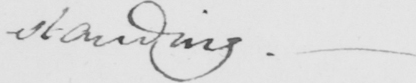Transcribe the text shown in this historical manuscript line. standing . _ 